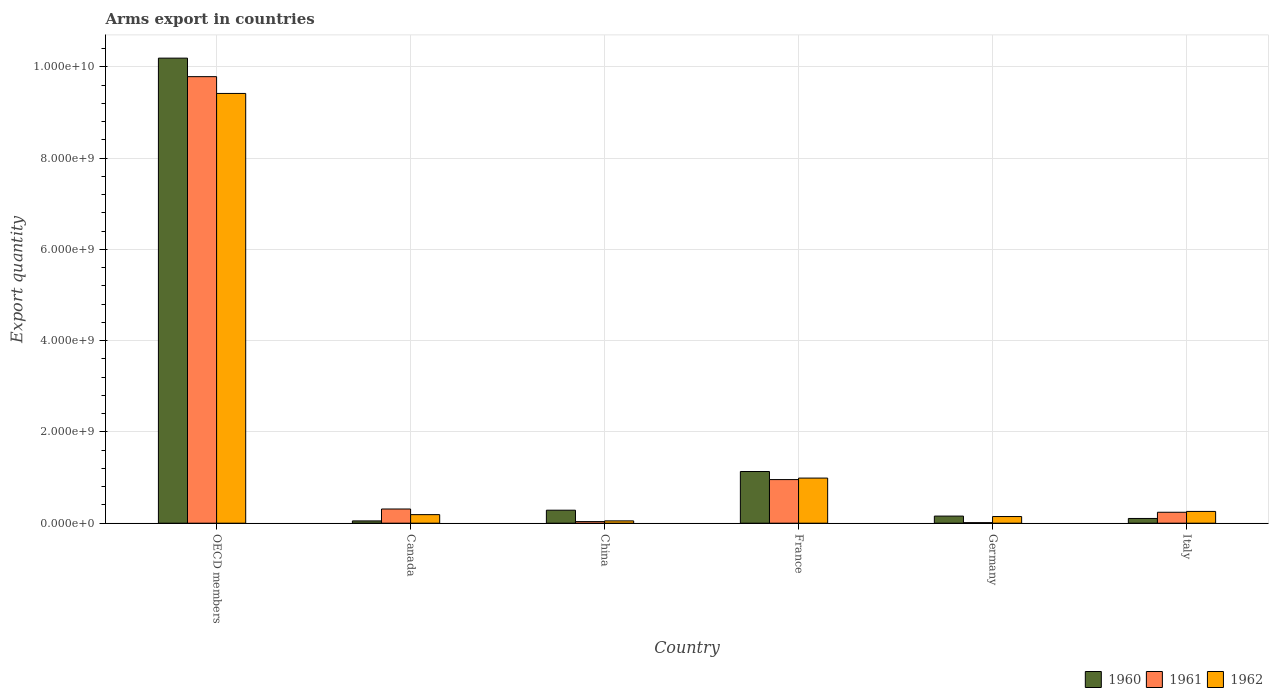How many groups of bars are there?
Provide a short and direct response. 6. Are the number of bars per tick equal to the number of legend labels?
Offer a terse response. Yes. Are the number of bars on each tick of the X-axis equal?
Your response must be concise. Yes. How many bars are there on the 6th tick from the left?
Make the answer very short. 3. How many bars are there on the 1st tick from the right?
Keep it short and to the point. 3. What is the total arms export in 1962 in France?
Keep it short and to the point. 9.89e+08. Across all countries, what is the maximum total arms export in 1962?
Provide a succinct answer. 9.42e+09. Across all countries, what is the minimum total arms export in 1962?
Offer a terse response. 5.10e+07. In which country was the total arms export in 1960 maximum?
Your answer should be compact. OECD members. In which country was the total arms export in 1962 minimum?
Give a very brief answer. China. What is the total total arms export in 1962 in the graph?
Offer a terse response. 1.11e+1. What is the difference between the total arms export in 1960 in Canada and that in Italy?
Your answer should be very brief. -5.40e+07. What is the difference between the total arms export in 1962 in China and the total arms export in 1961 in Italy?
Your response must be concise. -1.89e+08. What is the average total arms export in 1962 per country?
Make the answer very short. 1.84e+09. What is the difference between the total arms export of/in 1961 and total arms export of/in 1962 in China?
Offer a very short reply. -1.60e+07. In how many countries, is the total arms export in 1961 greater than 2400000000?
Ensure brevity in your answer.  1. What is the ratio of the total arms export in 1960 in France to that in Italy?
Ensure brevity in your answer.  10.89. Is the total arms export in 1962 in China less than that in France?
Your answer should be compact. Yes. What is the difference between the highest and the second highest total arms export in 1960?
Your response must be concise. 9.91e+09. What is the difference between the highest and the lowest total arms export in 1961?
Offer a very short reply. 9.78e+09. In how many countries, is the total arms export in 1961 greater than the average total arms export in 1961 taken over all countries?
Make the answer very short. 1. Is the sum of the total arms export in 1962 in Canada and Germany greater than the maximum total arms export in 1961 across all countries?
Keep it short and to the point. No. What does the 3rd bar from the left in Italy represents?
Your response must be concise. 1962. Are all the bars in the graph horizontal?
Make the answer very short. No. Are the values on the major ticks of Y-axis written in scientific E-notation?
Ensure brevity in your answer.  Yes. Does the graph contain any zero values?
Your answer should be very brief. No. Does the graph contain grids?
Give a very brief answer. Yes. Where does the legend appear in the graph?
Your response must be concise. Bottom right. How are the legend labels stacked?
Offer a terse response. Horizontal. What is the title of the graph?
Make the answer very short. Arms export in countries. What is the label or title of the X-axis?
Your answer should be very brief. Country. What is the label or title of the Y-axis?
Give a very brief answer. Export quantity. What is the Export quantity of 1960 in OECD members?
Provide a succinct answer. 1.02e+1. What is the Export quantity of 1961 in OECD members?
Make the answer very short. 9.79e+09. What is the Export quantity of 1962 in OECD members?
Your answer should be very brief. 9.42e+09. What is the Export quantity of 1960 in Canada?
Your answer should be very brief. 5.00e+07. What is the Export quantity of 1961 in Canada?
Your answer should be very brief. 3.11e+08. What is the Export quantity of 1962 in Canada?
Keep it short and to the point. 1.88e+08. What is the Export quantity in 1960 in China?
Provide a succinct answer. 2.85e+08. What is the Export quantity of 1961 in China?
Your answer should be very brief. 3.50e+07. What is the Export quantity of 1962 in China?
Provide a short and direct response. 5.10e+07. What is the Export quantity in 1960 in France?
Keep it short and to the point. 1.13e+09. What is the Export quantity in 1961 in France?
Give a very brief answer. 9.56e+08. What is the Export quantity of 1962 in France?
Keep it short and to the point. 9.89e+08. What is the Export quantity of 1960 in Germany?
Make the answer very short. 1.56e+08. What is the Export quantity of 1961 in Germany?
Make the answer very short. 1.20e+07. What is the Export quantity in 1962 in Germany?
Give a very brief answer. 1.46e+08. What is the Export quantity of 1960 in Italy?
Provide a short and direct response. 1.04e+08. What is the Export quantity in 1961 in Italy?
Your answer should be compact. 2.40e+08. What is the Export quantity in 1962 in Italy?
Your answer should be compact. 2.58e+08. Across all countries, what is the maximum Export quantity of 1960?
Keep it short and to the point. 1.02e+1. Across all countries, what is the maximum Export quantity of 1961?
Provide a succinct answer. 9.79e+09. Across all countries, what is the maximum Export quantity of 1962?
Keep it short and to the point. 9.42e+09. Across all countries, what is the minimum Export quantity of 1962?
Make the answer very short. 5.10e+07. What is the total Export quantity in 1960 in the graph?
Keep it short and to the point. 1.19e+1. What is the total Export quantity in 1961 in the graph?
Provide a short and direct response. 1.13e+1. What is the total Export quantity in 1962 in the graph?
Keep it short and to the point. 1.11e+1. What is the difference between the Export quantity of 1960 in OECD members and that in Canada?
Give a very brief answer. 1.01e+1. What is the difference between the Export quantity of 1961 in OECD members and that in Canada?
Give a very brief answer. 9.48e+09. What is the difference between the Export quantity in 1962 in OECD members and that in Canada?
Provide a short and direct response. 9.23e+09. What is the difference between the Export quantity of 1960 in OECD members and that in China?
Offer a terse response. 9.91e+09. What is the difference between the Export quantity in 1961 in OECD members and that in China?
Give a very brief answer. 9.75e+09. What is the difference between the Export quantity of 1962 in OECD members and that in China?
Provide a succinct answer. 9.37e+09. What is the difference between the Export quantity of 1960 in OECD members and that in France?
Give a very brief answer. 9.06e+09. What is the difference between the Export quantity in 1961 in OECD members and that in France?
Provide a short and direct response. 8.83e+09. What is the difference between the Export quantity in 1962 in OECD members and that in France?
Keep it short and to the point. 8.43e+09. What is the difference between the Export quantity in 1960 in OECD members and that in Germany?
Offer a very short reply. 1.00e+1. What is the difference between the Export quantity of 1961 in OECD members and that in Germany?
Your response must be concise. 9.78e+09. What is the difference between the Export quantity of 1962 in OECD members and that in Germany?
Your answer should be very brief. 9.27e+09. What is the difference between the Export quantity of 1960 in OECD members and that in Italy?
Ensure brevity in your answer.  1.01e+1. What is the difference between the Export quantity in 1961 in OECD members and that in Italy?
Ensure brevity in your answer.  9.55e+09. What is the difference between the Export quantity of 1962 in OECD members and that in Italy?
Keep it short and to the point. 9.16e+09. What is the difference between the Export quantity in 1960 in Canada and that in China?
Keep it short and to the point. -2.35e+08. What is the difference between the Export quantity of 1961 in Canada and that in China?
Keep it short and to the point. 2.76e+08. What is the difference between the Export quantity of 1962 in Canada and that in China?
Provide a short and direct response. 1.37e+08. What is the difference between the Export quantity of 1960 in Canada and that in France?
Your response must be concise. -1.08e+09. What is the difference between the Export quantity in 1961 in Canada and that in France?
Your answer should be very brief. -6.45e+08. What is the difference between the Export quantity in 1962 in Canada and that in France?
Offer a terse response. -8.01e+08. What is the difference between the Export quantity of 1960 in Canada and that in Germany?
Make the answer very short. -1.06e+08. What is the difference between the Export quantity of 1961 in Canada and that in Germany?
Offer a terse response. 2.99e+08. What is the difference between the Export quantity in 1962 in Canada and that in Germany?
Keep it short and to the point. 4.20e+07. What is the difference between the Export quantity of 1960 in Canada and that in Italy?
Keep it short and to the point. -5.40e+07. What is the difference between the Export quantity of 1961 in Canada and that in Italy?
Give a very brief answer. 7.10e+07. What is the difference between the Export quantity in 1962 in Canada and that in Italy?
Provide a short and direct response. -7.00e+07. What is the difference between the Export quantity in 1960 in China and that in France?
Your answer should be compact. -8.48e+08. What is the difference between the Export quantity of 1961 in China and that in France?
Offer a terse response. -9.21e+08. What is the difference between the Export quantity in 1962 in China and that in France?
Offer a terse response. -9.38e+08. What is the difference between the Export quantity of 1960 in China and that in Germany?
Offer a terse response. 1.29e+08. What is the difference between the Export quantity in 1961 in China and that in Germany?
Offer a very short reply. 2.30e+07. What is the difference between the Export quantity in 1962 in China and that in Germany?
Provide a succinct answer. -9.50e+07. What is the difference between the Export quantity in 1960 in China and that in Italy?
Offer a very short reply. 1.81e+08. What is the difference between the Export quantity in 1961 in China and that in Italy?
Offer a very short reply. -2.05e+08. What is the difference between the Export quantity in 1962 in China and that in Italy?
Give a very brief answer. -2.07e+08. What is the difference between the Export quantity of 1960 in France and that in Germany?
Ensure brevity in your answer.  9.77e+08. What is the difference between the Export quantity in 1961 in France and that in Germany?
Offer a terse response. 9.44e+08. What is the difference between the Export quantity of 1962 in France and that in Germany?
Your answer should be compact. 8.43e+08. What is the difference between the Export quantity in 1960 in France and that in Italy?
Provide a succinct answer. 1.03e+09. What is the difference between the Export quantity of 1961 in France and that in Italy?
Your answer should be compact. 7.16e+08. What is the difference between the Export quantity in 1962 in France and that in Italy?
Make the answer very short. 7.31e+08. What is the difference between the Export quantity of 1960 in Germany and that in Italy?
Keep it short and to the point. 5.20e+07. What is the difference between the Export quantity in 1961 in Germany and that in Italy?
Provide a short and direct response. -2.28e+08. What is the difference between the Export quantity in 1962 in Germany and that in Italy?
Your answer should be very brief. -1.12e+08. What is the difference between the Export quantity of 1960 in OECD members and the Export quantity of 1961 in Canada?
Make the answer very short. 9.88e+09. What is the difference between the Export quantity of 1960 in OECD members and the Export quantity of 1962 in Canada?
Your answer should be very brief. 1.00e+1. What is the difference between the Export quantity in 1961 in OECD members and the Export quantity in 1962 in Canada?
Your answer should be very brief. 9.60e+09. What is the difference between the Export quantity in 1960 in OECD members and the Export quantity in 1961 in China?
Offer a terse response. 1.02e+1. What is the difference between the Export quantity in 1960 in OECD members and the Export quantity in 1962 in China?
Your answer should be very brief. 1.01e+1. What is the difference between the Export quantity of 1961 in OECD members and the Export quantity of 1962 in China?
Your answer should be compact. 9.74e+09. What is the difference between the Export quantity in 1960 in OECD members and the Export quantity in 1961 in France?
Offer a terse response. 9.24e+09. What is the difference between the Export quantity in 1960 in OECD members and the Export quantity in 1962 in France?
Offer a terse response. 9.20e+09. What is the difference between the Export quantity of 1961 in OECD members and the Export quantity of 1962 in France?
Give a very brief answer. 8.80e+09. What is the difference between the Export quantity of 1960 in OECD members and the Export quantity of 1961 in Germany?
Keep it short and to the point. 1.02e+1. What is the difference between the Export quantity in 1960 in OECD members and the Export quantity in 1962 in Germany?
Your answer should be very brief. 1.00e+1. What is the difference between the Export quantity in 1961 in OECD members and the Export quantity in 1962 in Germany?
Provide a succinct answer. 9.64e+09. What is the difference between the Export quantity in 1960 in OECD members and the Export quantity in 1961 in Italy?
Make the answer very short. 9.95e+09. What is the difference between the Export quantity of 1960 in OECD members and the Export quantity of 1962 in Italy?
Your answer should be compact. 9.94e+09. What is the difference between the Export quantity of 1961 in OECD members and the Export quantity of 1962 in Italy?
Give a very brief answer. 9.53e+09. What is the difference between the Export quantity in 1960 in Canada and the Export quantity in 1961 in China?
Make the answer very short. 1.50e+07. What is the difference between the Export quantity in 1960 in Canada and the Export quantity in 1962 in China?
Offer a terse response. -1.00e+06. What is the difference between the Export quantity of 1961 in Canada and the Export quantity of 1962 in China?
Your answer should be compact. 2.60e+08. What is the difference between the Export quantity of 1960 in Canada and the Export quantity of 1961 in France?
Your answer should be compact. -9.06e+08. What is the difference between the Export quantity in 1960 in Canada and the Export quantity in 1962 in France?
Provide a short and direct response. -9.39e+08. What is the difference between the Export quantity in 1961 in Canada and the Export quantity in 1962 in France?
Provide a short and direct response. -6.78e+08. What is the difference between the Export quantity of 1960 in Canada and the Export quantity of 1961 in Germany?
Your answer should be compact. 3.80e+07. What is the difference between the Export quantity in 1960 in Canada and the Export quantity in 1962 in Germany?
Provide a short and direct response. -9.60e+07. What is the difference between the Export quantity in 1961 in Canada and the Export quantity in 1962 in Germany?
Offer a terse response. 1.65e+08. What is the difference between the Export quantity in 1960 in Canada and the Export quantity in 1961 in Italy?
Keep it short and to the point. -1.90e+08. What is the difference between the Export quantity in 1960 in Canada and the Export quantity in 1962 in Italy?
Your answer should be compact. -2.08e+08. What is the difference between the Export quantity in 1961 in Canada and the Export quantity in 1962 in Italy?
Provide a succinct answer. 5.30e+07. What is the difference between the Export quantity of 1960 in China and the Export quantity of 1961 in France?
Make the answer very short. -6.71e+08. What is the difference between the Export quantity in 1960 in China and the Export quantity in 1962 in France?
Offer a very short reply. -7.04e+08. What is the difference between the Export quantity of 1961 in China and the Export quantity of 1962 in France?
Your answer should be very brief. -9.54e+08. What is the difference between the Export quantity of 1960 in China and the Export quantity of 1961 in Germany?
Make the answer very short. 2.73e+08. What is the difference between the Export quantity of 1960 in China and the Export quantity of 1962 in Germany?
Ensure brevity in your answer.  1.39e+08. What is the difference between the Export quantity of 1961 in China and the Export quantity of 1962 in Germany?
Provide a succinct answer. -1.11e+08. What is the difference between the Export quantity of 1960 in China and the Export quantity of 1961 in Italy?
Provide a succinct answer. 4.50e+07. What is the difference between the Export quantity in 1960 in China and the Export quantity in 1962 in Italy?
Your answer should be very brief. 2.70e+07. What is the difference between the Export quantity in 1961 in China and the Export quantity in 1962 in Italy?
Ensure brevity in your answer.  -2.23e+08. What is the difference between the Export quantity in 1960 in France and the Export quantity in 1961 in Germany?
Provide a short and direct response. 1.12e+09. What is the difference between the Export quantity in 1960 in France and the Export quantity in 1962 in Germany?
Ensure brevity in your answer.  9.87e+08. What is the difference between the Export quantity in 1961 in France and the Export quantity in 1962 in Germany?
Make the answer very short. 8.10e+08. What is the difference between the Export quantity in 1960 in France and the Export quantity in 1961 in Italy?
Provide a short and direct response. 8.93e+08. What is the difference between the Export quantity in 1960 in France and the Export quantity in 1962 in Italy?
Your response must be concise. 8.75e+08. What is the difference between the Export quantity of 1961 in France and the Export quantity of 1962 in Italy?
Your answer should be compact. 6.98e+08. What is the difference between the Export quantity of 1960 in Germany and the Export quantity of 1961 in Italy?
Your answer should be very brief. -8.40e+07. What is the difference between the Export quantity of 1960 in Germany and the Export quantity of 1962 in Italy?
Make the answer very short. -1.02e+08. What is the difference between the Export quantity in 1961 in Germany and the Export quantity in 1962 in Italy?
Offer a terse response. -2.46e+08. What is the average Export quantity of 1960 per country?
Give a very brief answer. 1.99e+09. What is the average Export quantity in 1961 per country?
Offer a terse response. 1.89e+09. What is the average Export quantity of 1962 per country?
Provide a succinct answer. 1.84e+09. What is the difference between the Export quantity in 1960 and Export quantity in 1961 in OECD members?
Offer a terse response. 4.06e+08. What is the difference between the Export quantity of 1960 and Export quantity of 1962 in OECD members?
Provide a short and direct response. 7.74e+08. What is the difference between the Export quantity in 1961 and Export quantity in 1962 in OECD members?
Give a very brief answer. 3.68e+08. What is the difference between the Export quantity in 1960 and Export quantity in 1961 in Canada?
Your response must be concise. -2.61e+08. What is the difference between the Export quantity of 1960 and Export quantity of 1962 in Canada?
Your answer should be very brief. -1.38e+08. What is the difference between the Export quantity in 1961 and Export quantity in 1962 in Canada?
Make the answer very short. 1.23e+08. What is the difference between the Export quantity in 1960 and Export quantity in 1961 in China?
Offer a very short reply. 2.50e+08. What is the difference between the Export quantity of 1960 and Export quantity of 1962 in China?
Your answer should be very brief. 2.34e+08. What is the difference between the Export quantity in 1961 and Export quantity in 1962 in China?
Provide a succinct answer. -1.60e+07. What is the difference between the Export quantity of 1960 and Export quantity of 1961 in France?
Make the answer very short. 1.77e+08. What is the difference between the Export quantity in 1960 and Export quantity in 1962 in France?
Provide a short and direct response. 1.44e+08. What is the difference between the Export quantity in 1961 and Export quantity in 1962 in France?
Keep it short and to the point. -3.30e+07. What is the difference between the Export quantity in 1960 and Export quantity in 1961 in Germany?
Offer a terse response. 1.44e+08. What is the difference between the Export quantity in 1961 and Export quantity in 1962 in Germany?
Keep it short and to the point. -1.34e+08. What is the difference between the Export quantity in 1960 and Export quantity in 1961 in Italy?
Provide a succinct answer. -1.36e+08. What is the difference between the Export quantity of 1960 and Export quantity of 1962 in Italy?
Provide a short and direct response. -1.54e+08. What is the difference between the Export quantity in 1961 and Export quantity in 1962 in Italy?
Your answer should be compact. -1.80e+07. What is the ratio of the Export quantity in 1960 in OECD members to that in Canada?
Provide a short and direct response. 203.88. What is the ratio of the Export quantity of 1961 in OECD members to that in Canada?
Offer a terse response. 31.47. What is the ratio of the Export quantity of 1962 in OECD members to that in Canada?
Ensure brevity in your answer.  50.11. What is the ratio of the Export quantity in 1960 in OECD members to that in China?
Provide a short and direct response. 35.77. What is the ratio of the Export quantity of 1961 in OECD members to that in China?
Provide a short and direct response. 279.66. What is the ratio of the Export quantity in 1962 in OECD members to that in China?
Give a very brief answer. 184.71. What is the ratio of the Export quantity in 1960 in OECD members to that in France?
Provide a succinct answer. 9. What is the ratio of the Export quantity in 1961 in OECD members to that in France?
Give a very brief answer. 10.24. What is the ratio of the Export quantity of 1962 in OECD members to that in France?
Keep it short and to the point. 9.52. What is the ratio of the Export quantity of 1960 in OECD members to that in Germany?
Offer a very short reply. 65.35. What is the ratio of the Export quantity in 1961 in OECD members to that in Germany?
Offer a terse response. 815.67. What is the ratio of the Export quantity of 1962 in OECD members to that in Germany?
Keep it short and to the point. 64.52. What is the ratio of the Export quantity of 1960 in OECD members to that in Italy?
Your answer should be very brief. 98.02. What is the ratio of the Export quantity in 1961 in OECD members to that in Italy?
Provide a short and direct response. 40.78. What is the ratio of the Export quantity in 1962 in OECD members to that in Italy?
Offer a very short reply. 36.51. What is the ratio of the Export quantity of 1960 in Canada to that in China?
Offer a very short reply. 0.18. What is the ratio of the Export quantity of 1961 in Canada to that in China?
Ensure brevity in your answer.  8.89. What is the ratio of the Export quantity of 1962 in Canada to that in China?
Provide a succinct answer. 3.69. What is the ratio of the Export quantity in 1960 in Canada to that in France?
Provide a short and direct response. 0.04. What is the ratio of the Export quantity of 1961 in Canada to that in France?
Offer a very short reply. 0.33. What is the ratio of the Export quantity in 1962 in Canada to that in France?
Your response must be concise. 0.19. What is the ratio of the Export quantity of 1960 in Canada to that in Germany?
Offer a very short reply. 0.32. What is the ratio of the Export quantity of 1961 in Canada to that in Germany?
Your answer should be compact. 25.92. What is the ratio of the Export quantity in 1962 in Canada to that in Germany?
Provide a succinct answer. 1.29. What is the ratio of the Export quantity of 1960 in Canada to that in Italy?
Make the answer very short. 0.48. What is the ratio of the Export quantity in 1961 in Canada to that in Italy?
Keep it short and to the point. 1.3. What is the ratio of the Export quantity of 1962 in Canada to that in Italy?
Make the answer very short. 0.73. What is the ratio of the Export quantity of 1960 in China to that in France?
Keep it short and to the point. 0.25. What is the ratio of the Export quantity in 1961 in China to that in France?
Give a very brief answer. 0.04. What is the ratio of the Export quantity in 1962 in China to that in France?
Your answer should be compact. 0.05. What is the ratio of the Export quantity of 1960 in China to that in Germany?
Provide a succinct answer. 1.83. What is the ratio of the Export quantity in 1961 in China to that in Germany?
Give a very brief answer. 2.92. What is the ratio of the Export quantity in 1962 in China to that in Germany?
Your answer should be very brief. 0.35. What is the ratio of the Export quantity of 1960 in China to that in Italy?
Your answer should be very brief. 2.74. What is the ratio of the Export quantity of 1961 in China to that in Italy?
Provide a short and direct response. 0.15. What is the ratio of the Export quantity of 1962 in China to that in Italy?
Make the answer very short. 0.2. What is the ratio of the Export quantity in 1960 in France to that in Germany?
Keep it short and to the point. 7.26. What is the ratio of the Export quantity of 1961 in France to that in Germany?
Offer a terse response. 79.67. What is the ratio of the Export quantity of 1962 in France to that in Germany?
Your answer should be very brief. 6.77. What is the ratio of the Export quantity in 1960 in France to that in Italy?
Make the answer very short. 10.89. What is the ratio of the Export quantity of 1961 in France to that in Italy?
Ensure brevity in your answer.  3.98. What is the ratio of the Export quantity in 1962 in France to that in Italy?
Offer a terse response. 3.83. What is the ratio of the Export quantity in 1962 in Germany to that in Italy?
Ensure brevity in your answer.  0.57. What is the difference between the highest and the second highest Export quantity of 1960?
Offer a terse response. 9.06e+09. What is the difference between the highest and the second highest Export quantity of 1961?
Your answer should be very brief. 8.83e+09. What is the difference between the highest and the second highest Export quantity in 1962?
Make the answer very short. 8.43e+09. What is the difference between the highest and the lowest Export quantity in 1960?
Keep it short and to the point. 1.01e+1. What is the difference between the highest and the lowest Export quantity of 1961?
Ensure brevity in your answer.  9.78e+09. What is the difference between the highest and the lowest Export quantity in 1962?
Make the answer very short. 9.37e+09. 